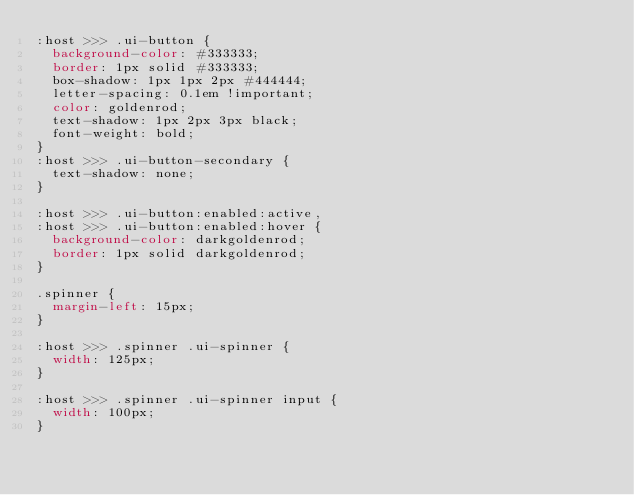<code> <loc_0><loc_0><loc_500><loc_500><_CSS_>:host >>> .ui-button {
  background-color: #333333;
  border: 1px solid #333333;
  box-shadow: 1px 1px 2px #444444;
  letter-spacing: 0.1em !important;
  color: goldenrod;
  text-shadow: 1px 2px 3px black;
  font-weight: bold;
}
:host >>> .ui-button-secondary {
  text-shadow: none;
}

:host >>> .ui-button:enabled:active,
:host >>> .ui-button:enabled:hover {
  background-color: darkgoldenrod;
  border: 1px solid darkgoldenrod;
}

.spinner {
  margin-left: 15px;
}

:host >>> .spinner .ui-spinner {
  width: 125px;
}

:host >>> .spinner .ui-spinner input {
  width: 100px;
}
</code> 